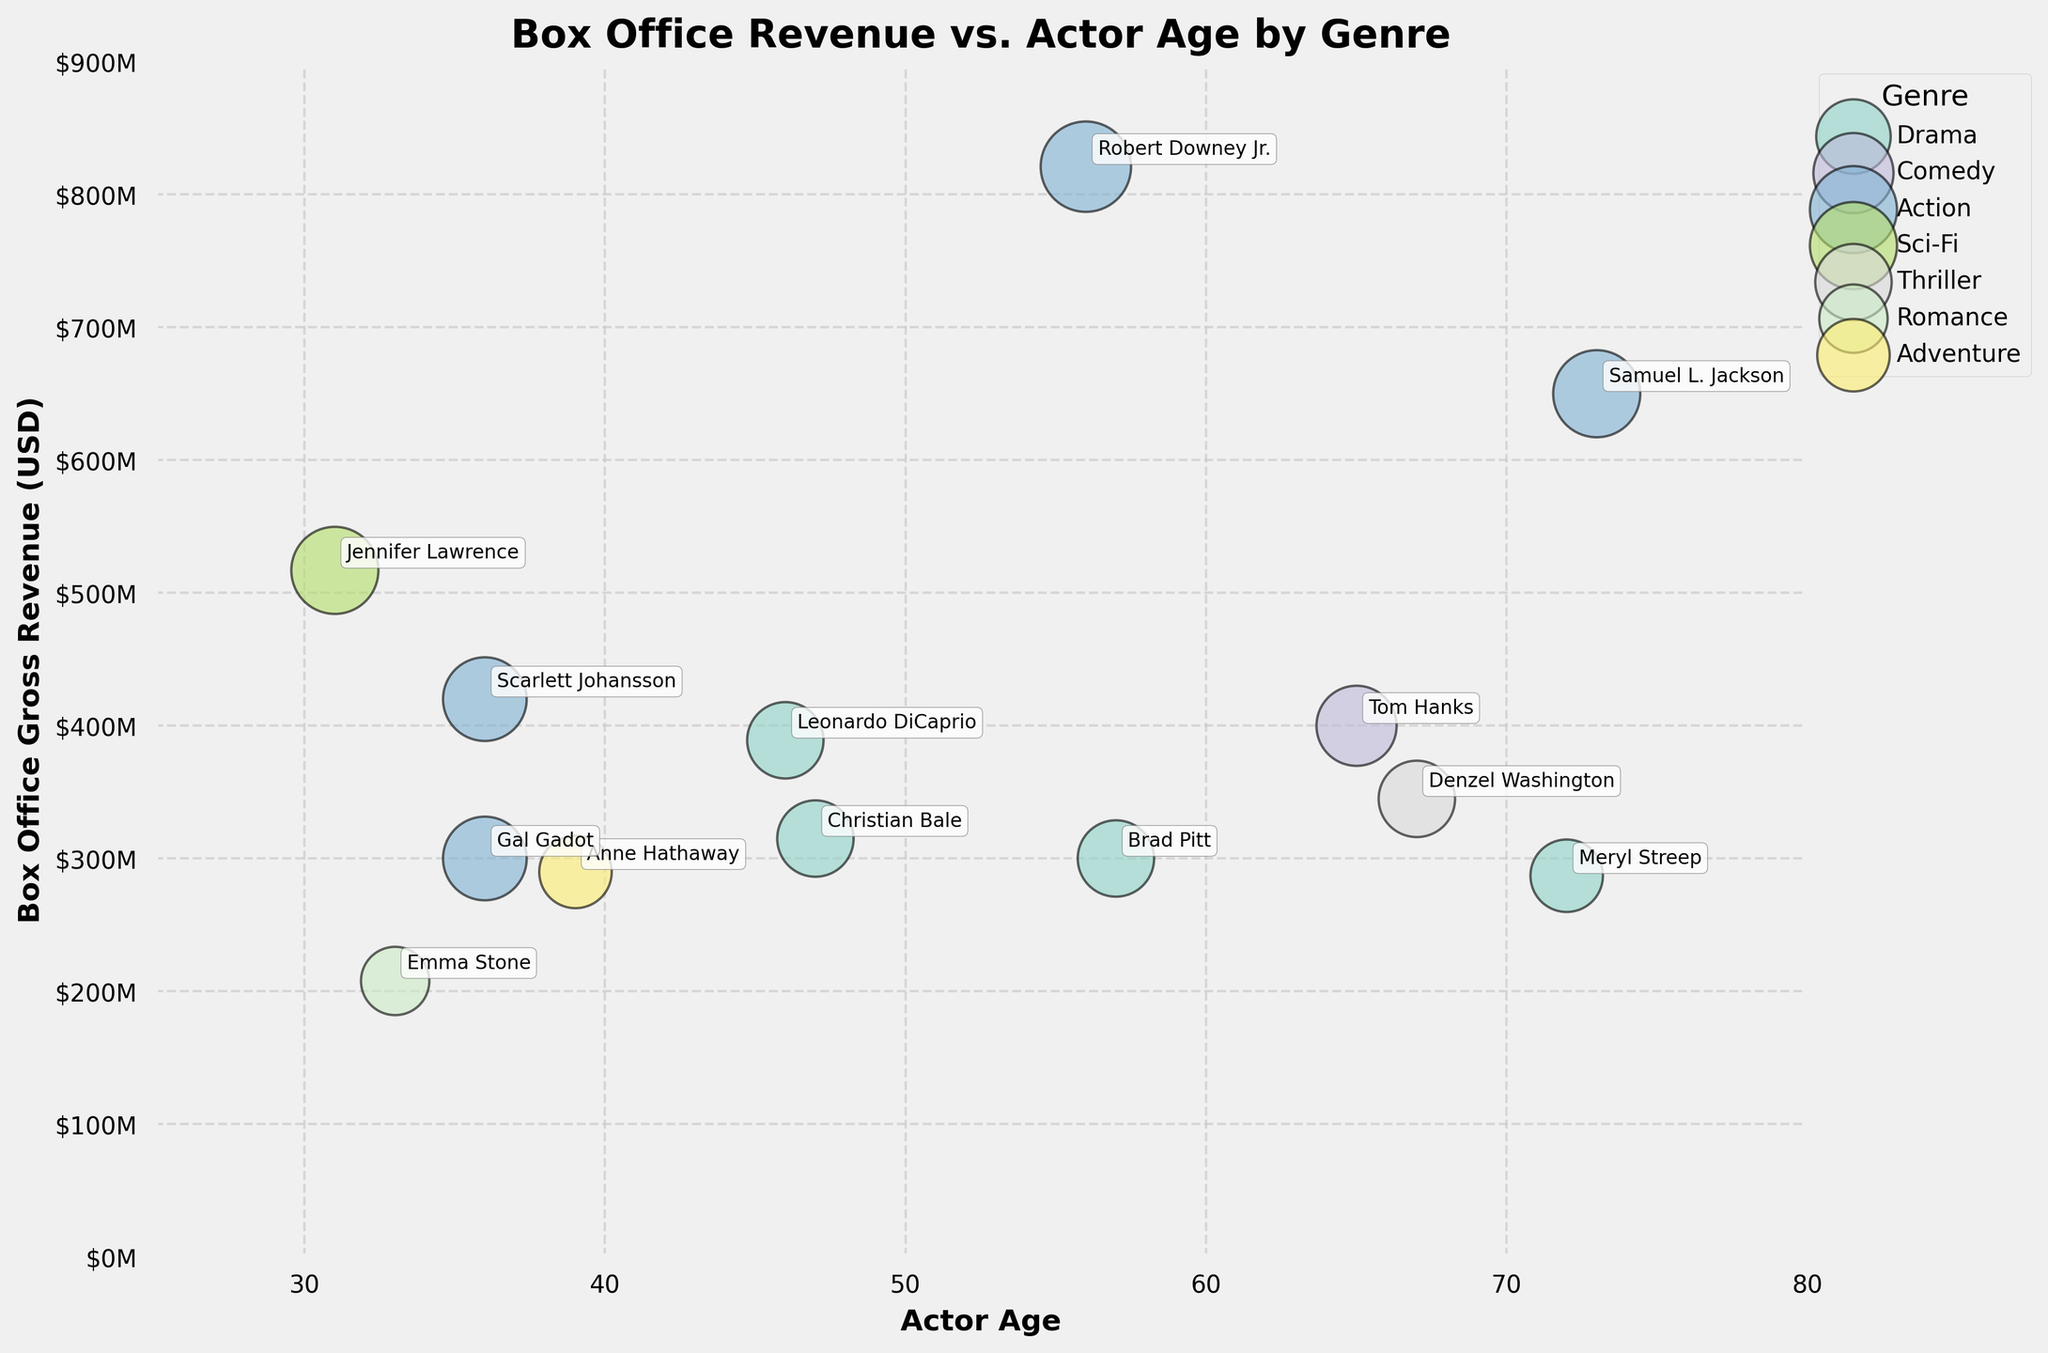What is the title of the plot? The title of the plot is located at the top center and reads "Box Office Revenue vs. Actor Age by Genre".
Answer: Box Office Revenue vs. Actor Age by Genre How many different genres are represented in the plot? By looking at the legend on the right side of the plot, there are seven genres listed with distinct colors.
Answer: Seven Which actor has the highest box office gross revenue? The transparent bubble appearing at the highest position on the y-axis indicates that Robert Downey Jr. has the highest box office gross revenue.
Answer: Robert Downey Jr What genre does Jennifer Lawrence represent? By finding the labeled bubble for Jennifer Lawrence and looking at its color, Jennifer Lawrence represents the Sci-Fi genre.
Answer: Sci-Fi How does the box office gross revenue of Meryl Streep compare to that of Leonardo DiCaprio? By comparing the vertical positions of Meryl Streep and Leonardo DiCaprio's bubbles, Meryl Streep has a lower box office gross revenue compared to Leonardo DiCaprio.
Answer: Meryl Streep has lower revenue What is the average age of the actors in the Drama genre? The ages of actors in the Drama genre are 46, 72, 47, and 57. Summing these and dividing by 4 gives (46 + 72 + 47 + 57) / 4 = 222 / 4 = 55.5.
Answer: 55.5 Which actor's bubble represents the largest size, indicating the highest scale of importance in the plot? By comparing the sizes of all visible bubbles, the largest bubble belongs to Robert Downey Jr.
Answer: Robert Downey Jr Arrange the genres in order of median box office gross revenue from highest to lowest. By finding the median box office gross revenue for each genre: Action (650M), Sci-Fi (517M), Comedy (400M), Thriller (345M), Drama (315M), Adventure (290M), Romance (208M).
Answer: Action, Sci-Fi, Comedy, Thriller, Drama, Adventure, Romance Is there a trend between actor age and box office gross revenue? Observing the plot, no clear trend (positive or negative correlation) is evident between actor age and box office gross revenue.
Answer: No clear trend Which actor in the Action genre has the lowest box office gross revenue, and what is it? By identifying the Action genre actors and comparing their bubble heights, Gal Gadot has the lowest box office gross revenue of 300M.
Answer: Gal Gadot, 300M 